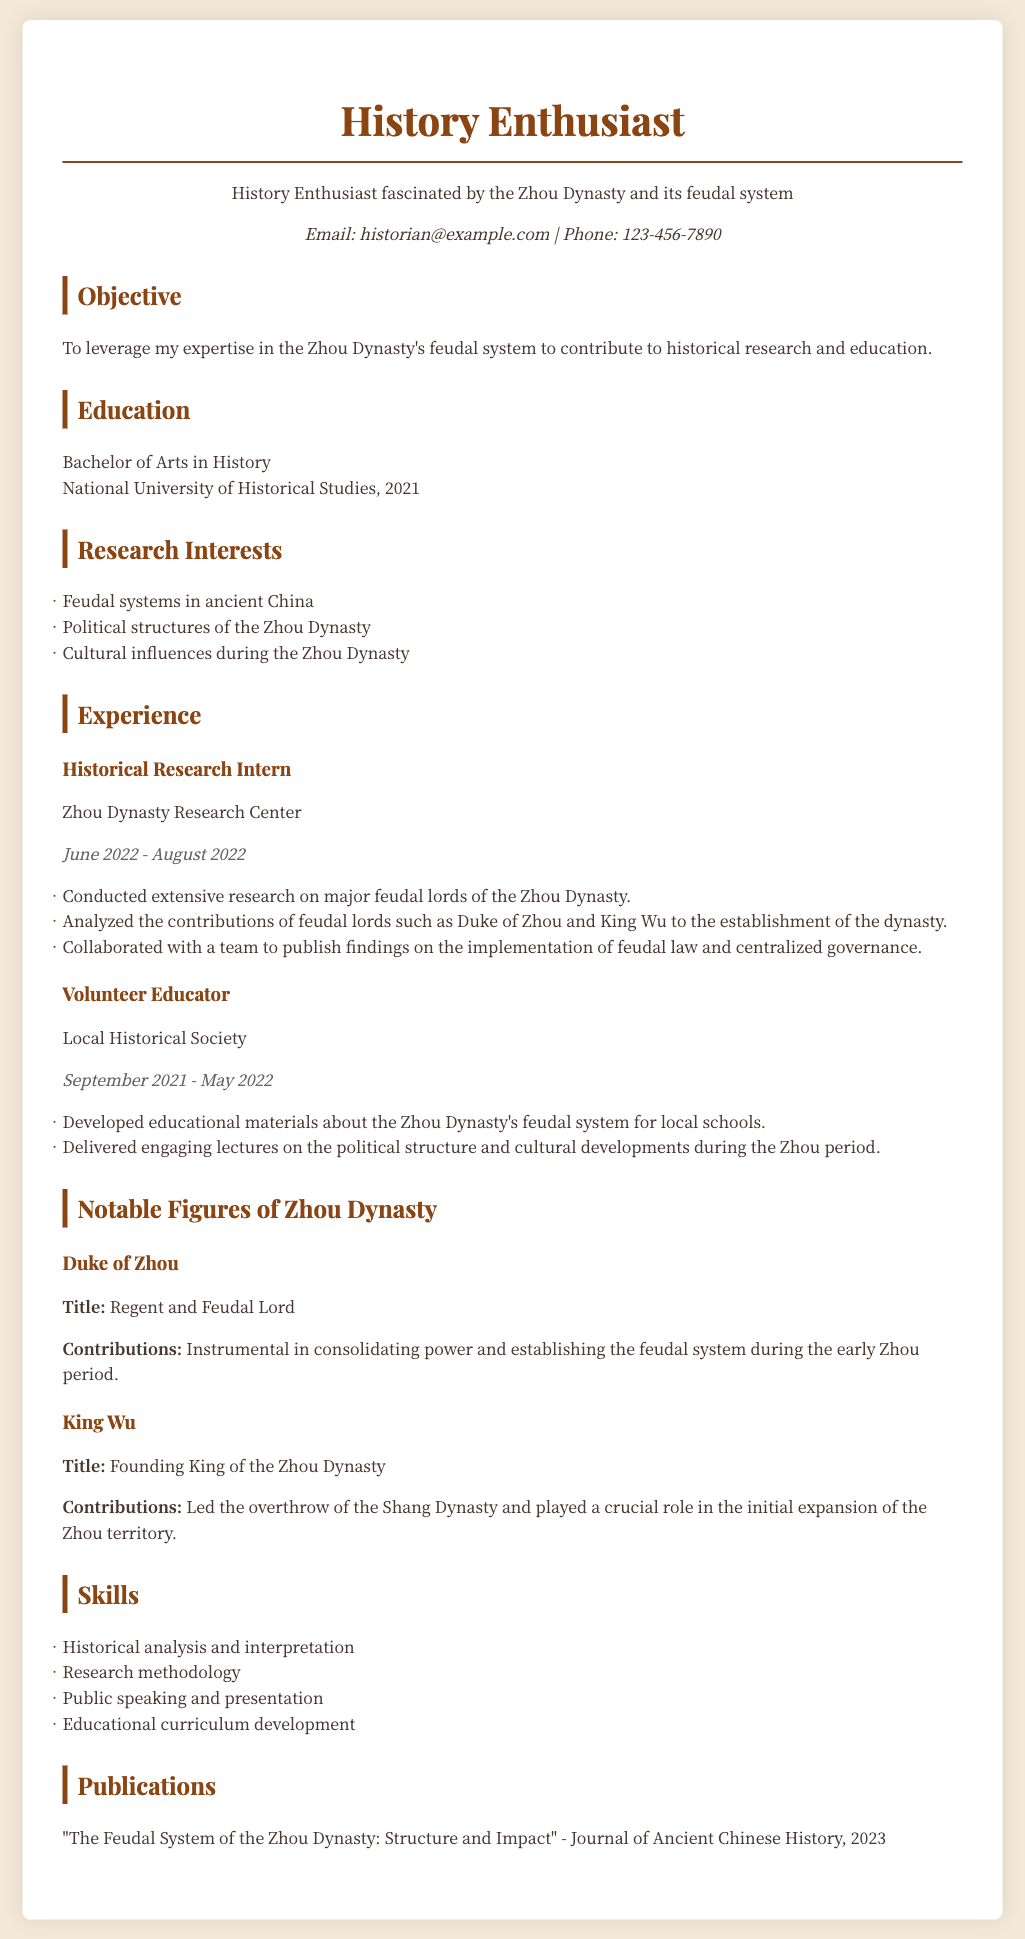what is the title of the document? The title is indicated in the header section, showcasing the individual's interest in history and a specific dynasty.
Answer: Zhou Dynasty Enthusiast CV who is the regent and feudal lord mentioned in the document? This information is found in the section detailing notable figures of the Zhou Dynasty, specifying their titles and contributions.
Answer: Duke of Zhou what institution did the individual graduate from? The document lists the individual's educational background, including the name of the university they attended.
Answer: National University of Historical Studies how long was the individual a Historical Research Intern? The duration of this role is provided in the experience section, showing the start and end dates of the position.
Answer: June 2022 - August 2022 which publication is listed in the document? The publication title is mentioned at the end of the CV under the publications section, indicating the focus of the research conducted.
Answer: The Feudal System of the Zhou Dynasty: Structure and Impact what is a skill mentioned in the CV? Skills are outlined in a specific section of the document, detailing the competencies of the individual related to historical research.
Answer: Historical analysis and interpretation which major feudal lord led the overthrow of the Shang Dynasty? The notable figures' contributions include key actions taken during their time, found in their description.
Answer: King Wu how many research interests are listed? The number of research interests is found in the dedicated section of the CV, indicating their focus areas.
Answer: Three 